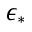Convert formula to latex. <formula><loc_0><loc_0><loc_500><loc_500>\epsilon _ { * }</formula> 